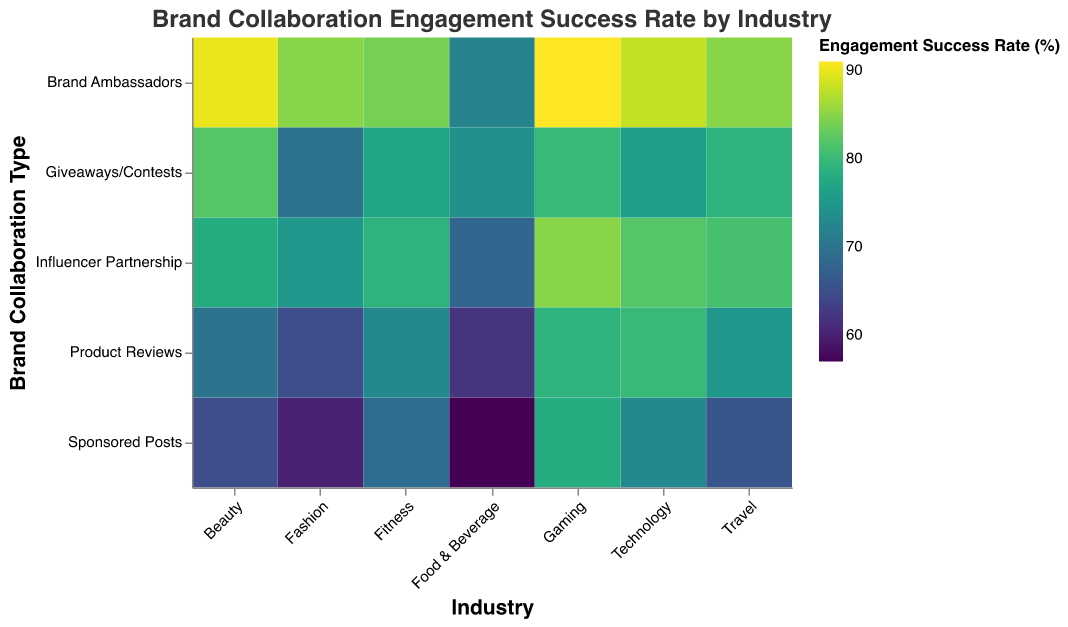What is the engagement success rate for influencer partnerships in the Gaming industry? Look at the cell where "Gaming" in the Industry column intersects with "Influencer Partnership" in the Brand Collaboration Type row; find the corresponding color and tooltip value.
Answer: 85 Which industry has the highest engagement success rate with brand ambassadors? Identify the cell with the highest engagement success rate in the "Brand Ambassadors" row by comparing the colors and values in the tooltips.
Answer: Gaming How does the engagement success rate for sponsored posts in the Fashion industry compare to the Technology industry? Locate the "Sponsored Posts" cells for both "Fashion" and "Technology" industries and compare their engagement success rates noted in the tooltips.
Answer: Technology has higher What is the average engagement success rate for product reviews across all industries? Find the engagement success rates for "Product Reviews" across all industries and calculate the average: (65 + 80 + 70 + 62 + 73 + 75 + 79) / 7.
Answer: 72 Which brand collaboration type has the most consistent engagement success rate across all industries? Compare the variation in colors among all brand collaboration types across all industries and determine which one shows the least color variation.
Answer: Brand Ambassadors In which industry do giveaways/contests have the lowest engagement success rate? Locate the row for "Giveaways/Contests" and identify the industry with the lowest engagement success rate based on color and tooltip values.
Answer: Fashion What's the difference in engagement success rate between influencer partnerships and brand ambassadors in the Fitness industry? Find the engagement success rates for "Influencer Partnership" and "Brand Ambassadors" in "Fitness" and subtract one from the other.
Answer: 5 Are sponsored posts more successful in the Beauty industry or the Food & Beverage industry? Compare the engagement success rates for "Sponsored Posts" in the "Beauty" and "Food & Beverage" industries by checking the colors and tooltip values.
Answer: Beauty Does the Travel industry perform better with giveaways/contests or product reviews? Compare the engagement success rates for "Giveaways/Contests" and "Product Reviews" in the "Travel" industry by checking the colors and values in the tooltip.
Answer: Giveaways/Contests Which industry and brand collaboration type combination has the overall highest engagement success rate? Scan the entire heatmap to find the cell with the highest engagement success rate by comparing colors and tooltip values.
Answer: Gaming with Brand Ambassadors 